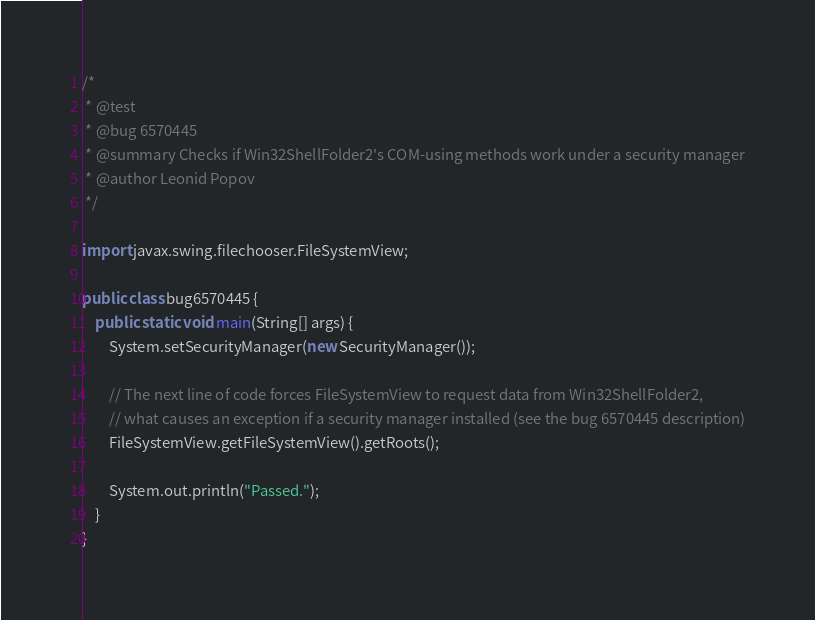Convert code to text. <code><loc_0><loc_0><loc_500><loc_500><_Java_>/*
 * @test
 * @bug 6570445
 * @summary Checks if Win32ShellFolder2's COM-using methods work under a security manager
 * @author Leonid Popov
 */

import javax.swing.filechooser.FileSystemView;

public class bug6570445 {
    public static void main(String[] args) {
        System.setSecurityManager(new SecurityManager());

        // The next line of code forces FileSystemView to request data from Win32ShellFolder2,
        // what causes an exception if a security manager installed (see the bug 6570445 description)
        FileSystemView.getFileSystemView().getRoots();

        System.out.println("Passed.");
    }
}
</code> 